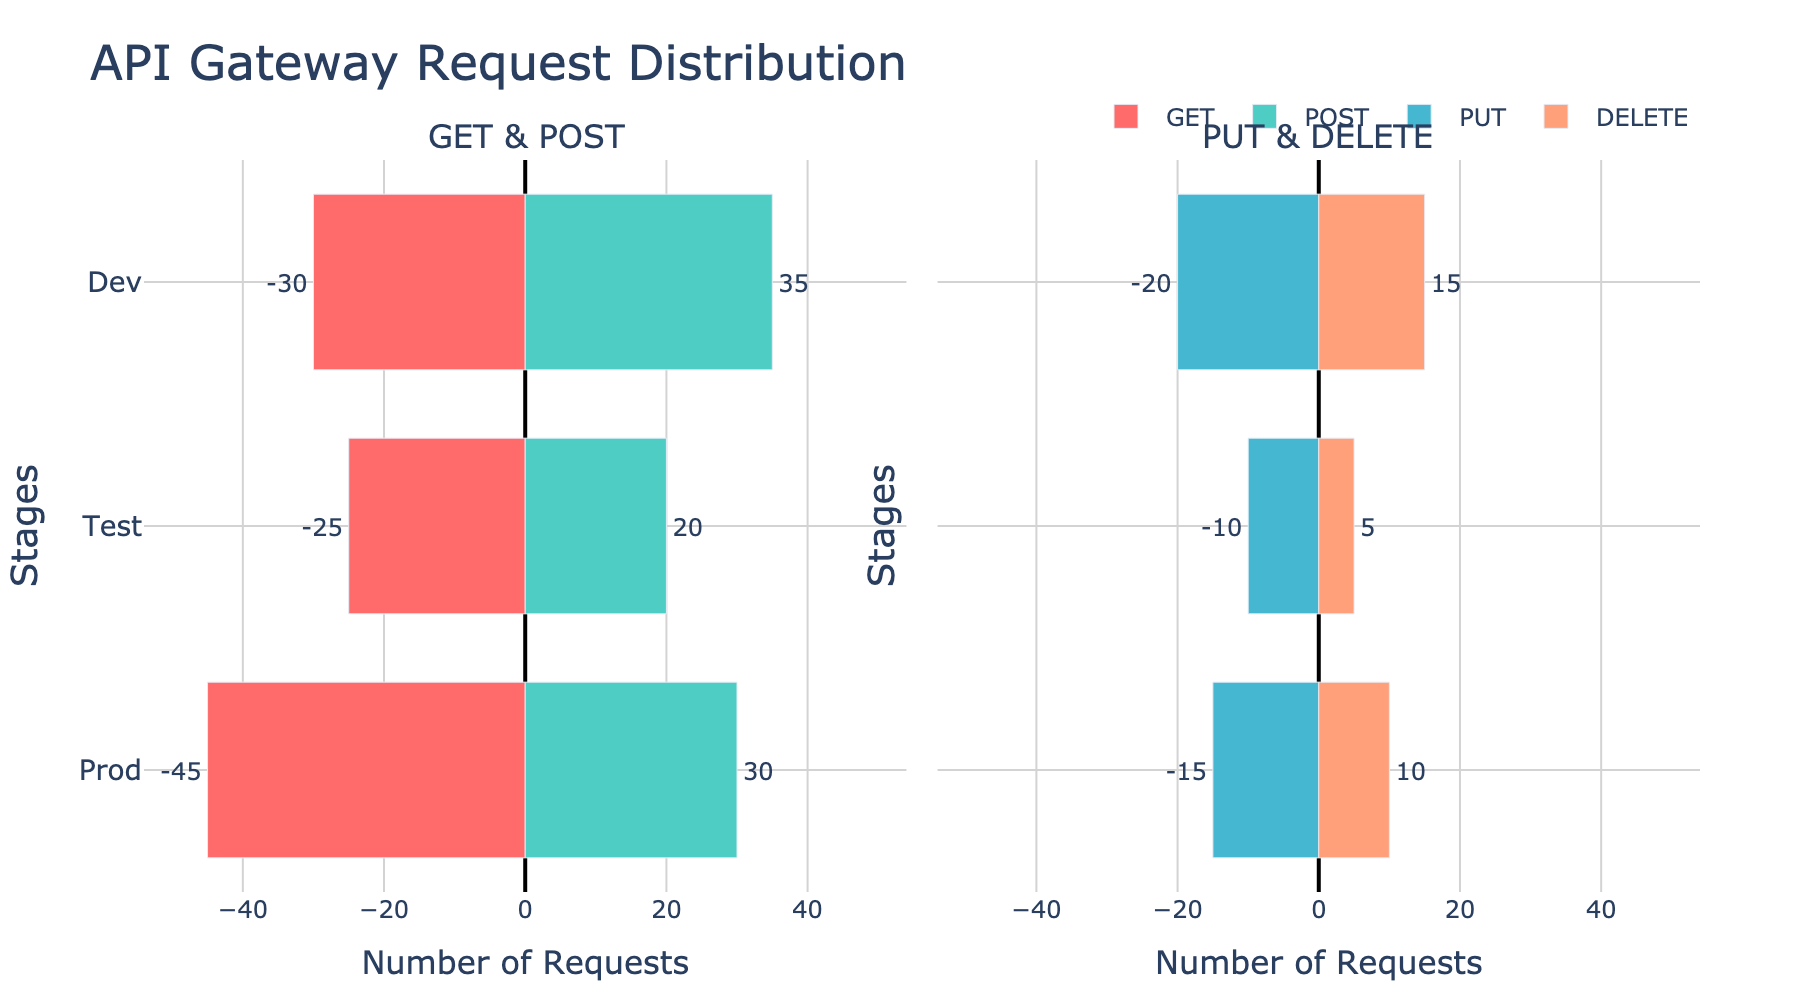What's the title of the figure? The title of the figure is usually located at the top center. Here, it reads "API Gateway Request Distribution."
Answer: API Gateway Request Distribution What stages are represented on the y-axis? The stages are typically listed vertically on the y-axis. In this case, 'Prod', 'Test', and 'Dev' are the stages shown.
Answer: Prod, Test, Dev How many GET requests are there in the 'Prod' stage? Look at the left side of the 'GET & POST' subplot for the 'Prod' stage. The number of requests is labeled just outside the bar for 'GET' requests. It shows 45 GET requests.
Answer: 45 Which HTTP method has the highest number of requests in the 'Dev' stage? Examine the bar lengths for each HTTP method in the 'Dev' stage. The POST requests have the longest bar, showing 35 requests.
Answer: POST Compare the number of DELETE requests in 'Prod' and 'Test' stages. Which is higher? Look at the 'DELETE' bars in the right subplot. The 'DELETE' bar in the 'Prod' stage is longer with 10 requests, compared to the 'Test' stage with 5 requests.
Answer: Prod What is the total number of requests in the 'Test' stage? Sum all the requests (GET, POST, PUT, DELETE) in the 'Test' stage: 25 (GET) + 20 (POST) + 10 (PUT) + 5 (DELETE) = 60 requests.
Answer: 60 What is the difference in the number of PUT requests between the 'Dev' and 'Prod' stages? The 'Dev' stage has 20 PUT requests, and the 'Prod' stage has 15 PUT requests. The difference is calculated as 20 - 15.
Answer: 5 What color represents the PUT requests in the figure? Look at the legend and the colors of the bars. PUT requests are shown in a blueish color. The specific color is #45B7D1.
Answer: Blueish (or #45B7D1) How does the number of GET requests in 'Dev' compare to 'Test'? Compare the lengths of the GET bars in the 'Dev' and 'Test' stages. The 'Dev' stage has 30 GET requests, and the 'Test' stage has 25 GET requests. The 'Dev' stage has more by 5 requests.
Answer: Dev has 5 more What is the average number of POST requests across all stages? Sum the POST requests across all stages: 30 (Prod) + 20 (Test) + 35 (Dev) = 85. Divide by the number of stages (3). The average is 85 / 3 ≈ 28.33.
Answer: 28.33 